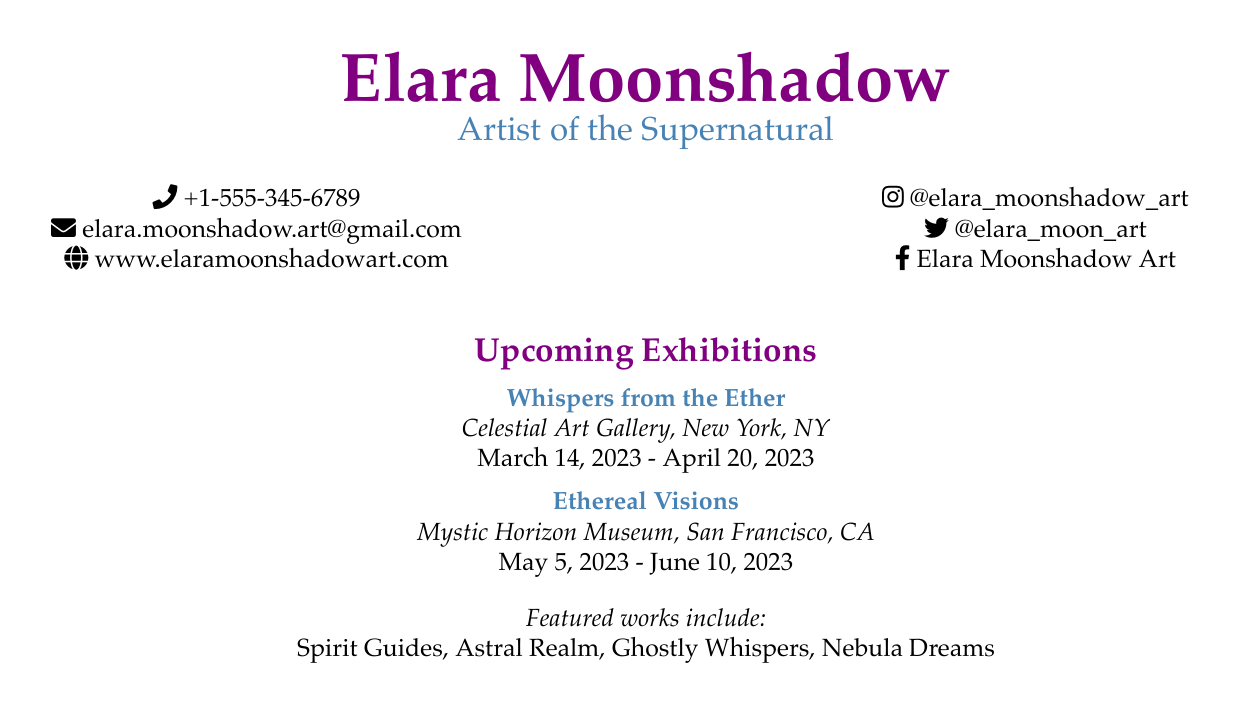What is the artist's name? The artist's name is prominently displayed at the top of the document.
Answer: Elara Moonshadow What is the venue for "Whispers from the Ether"? The venue is mentioned in the exhibition section of the document for this specific exhibition.
Answer: Celestial Art Gallery, New York, NY What is the date range for "Ethereal Visions"? The date range is outlined in the exhibition details for this specific show.
Answer: May 5, 2023 - June 10, 2023 How many exhibitions are listed in the document? The count of exhibitions can be determined by reviewing the listed entries in the upcoming exhibitions section.
Answer: 2 What is the email address provided? The email address is specified in the contact information portion of the card.
Answer: elara.moonshadow.art@gmail.com What type of themes do the featured works represent? The themes are reflected in the titles listed for the featured artworks.
Answer: Supernatural Who can you contact by phone? The phone number listed in the contact information indicates who can be contacted.
Answer: +1-555-345-6789 What style does Elara Moonshadow's art focus on? The artist's focus is indicated in the description beneath her name.
Answer: Supernatural What are included as featured works? Featured works are detailed as a list at the bottom of the card.
Answer: Spirit Guides, Astral Realm, Ghostly Whispers, Nebula Dreams 